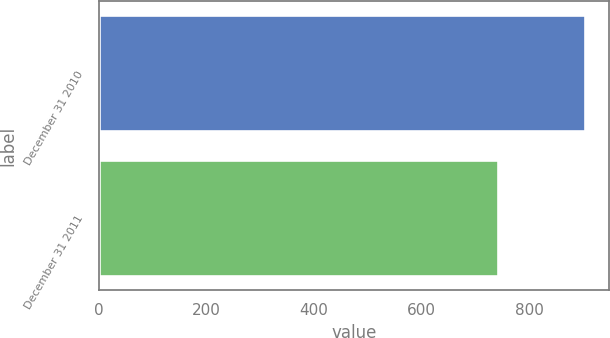<chart> <loc_0><loc_0><loc_500><loc_500><bar_chart><fcel>December 31 2010<fcel>December 31 2011<nl><fcel>903<fcel>742<nl></chart> 